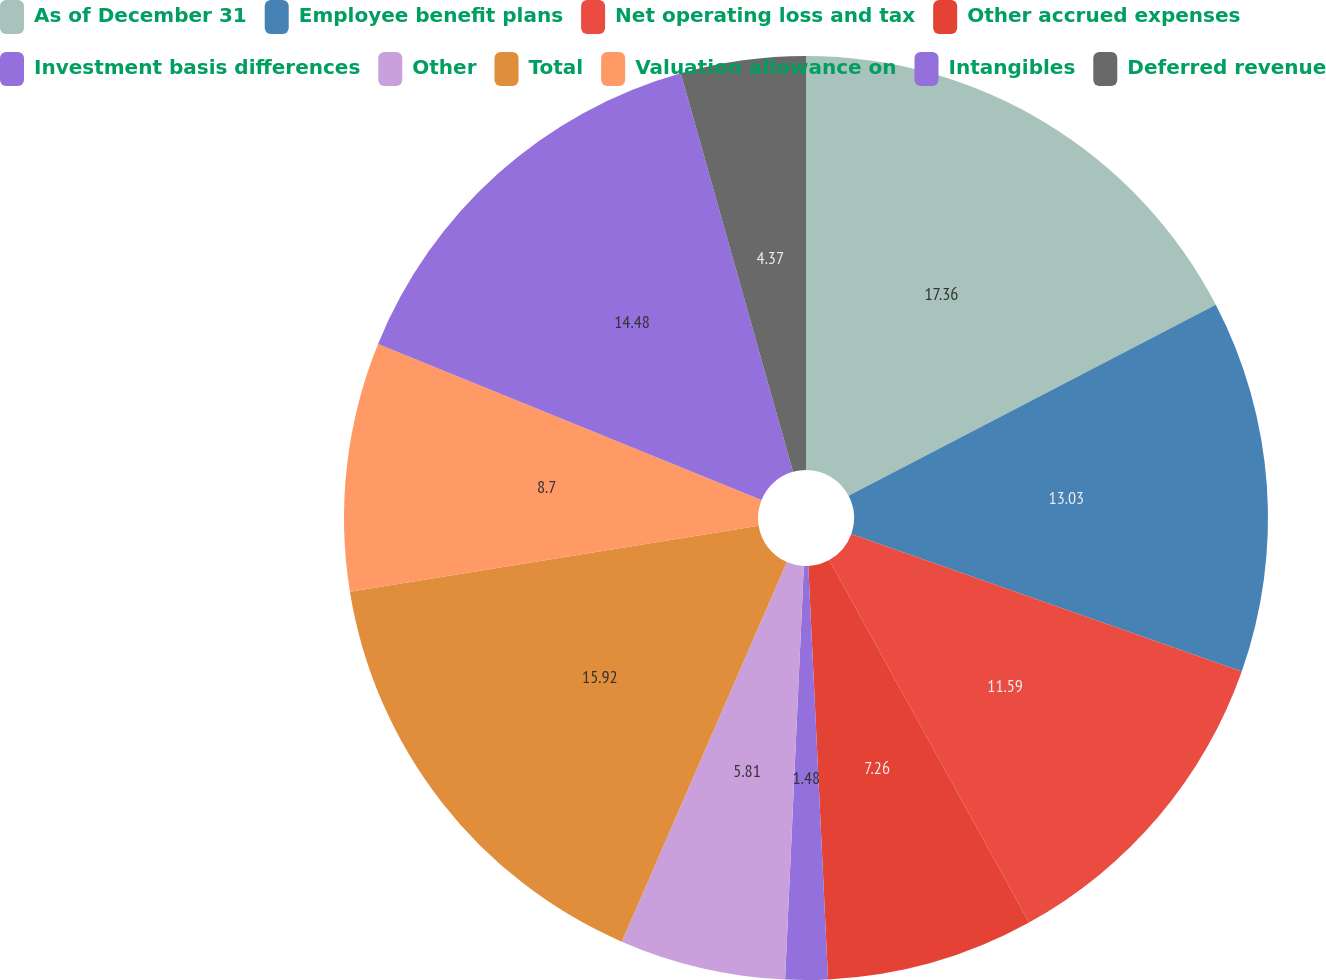<chart> <loc_0><loc_0><loc_500><loc_500><pie_chart><fcel>As of December 31<fcel>Employee benefit plans<fcel>Net operating loss and tax<fcel>Other accrued expenses<fcel>Investment basis differences<fcel>Other<fcel>Total<fcel>Valuation allowance on<fcel>Intangibles<fcel>Deferred revenue<nl><fcel>17.36%<fcel>13.03%<fcel>11.59%<fcel>7.26%<fcel>1.48%<fcel>5.81%<fcel>15.92%<fcel>8.7%<fcel>14.48%<fcel>4.37%<nl></chart> 